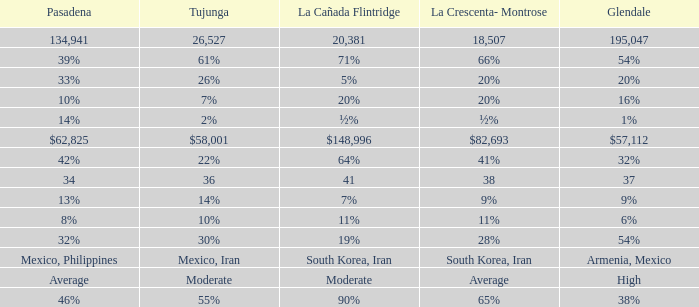What is the percentage of La Canada Flintridge when Tujunga is 7%? 20%. 